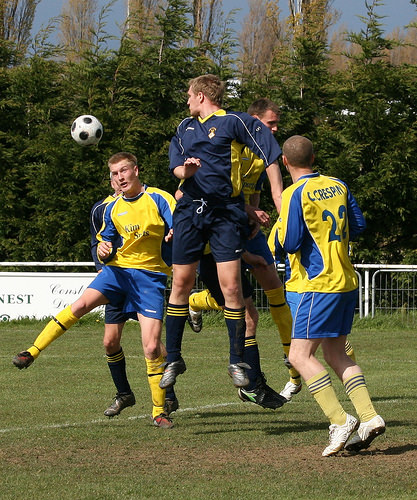<image>
Is there a sky behind the boy? Yes. From this viewpoint, the sky is positioned behind the boy, with the boy partially or fully occluding the sky. Is there a man above the ground? Yes. The man is positioned above the ground in the vertical space, higher up in the scene. 